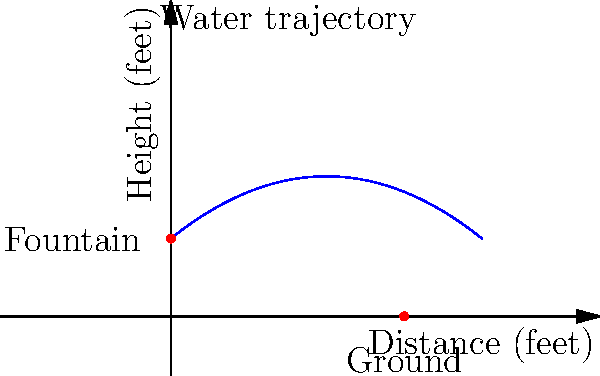You've installed a decorative fountain in your garden that shoots water in an arc. The trajectory of the water can be modeled by the function $h(x) = -0.1x^2 + 0.8x + 2$, where $h$ is the height of the water in feet and $x$ is the horizontal distance from the fountain in feet. At what horizontal distance from the fountain does the water hit the ground? To find where the water hits the ground, we need to solve the equation $h(x) = 0$:

1) Set up the equation:
   $-0.1x^2 + 0.8x + 2 = 0$

2) This is a quadratic equation. We can solve it using the quadratic formula:
   $x = \frac{-b \pm \sqrt{b^2 - 4ac}}{2a}$

   Where $a = -0.1$, $b = 0.8$, and $c = 2$

3) Plugging these values into the quadratic formula:
   $x = \frac{-0.8 \pm \sqrt{0.8^2 - 4(-0.1)(2)}}{2(-0.1)}$

4) Simplify:
   $x = \frac{-0.8 \pm \sqrt{0.64 + 0.8}}{-0.2} = \frac{-0.8 \pm \sqrt{1.44}}{-0.2} = \frac{-0.8 \pm 1.2}{-0.2}$

5) This gives us two solutions:
   $x = \frac{-0.8 + 1.2}{-0.2} = \frac{0.4}{-0.2} = -2$ or $x = \frac{-0.8 - 1.2}{-0.2} = \frac{-2}{-0.2} = 10$

6) Since distance cannot be negative, we discard the negative solution.

Therefore, the water hits the ground 10 feet from the fountain.
Answer: 10 feet 